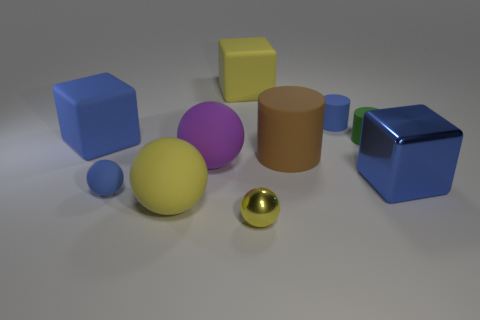Subtract all red spheres. Subtract all gray cylinders. How many spheres are left? 4 Subtract all blocks. How many objects are left? 7 Subtract all big metal cubes. Subtract all blue metallic blocks. How many objects are left? 8 Add 5 large yellow cubes. How many large yellow cubes are left? 6 Add 3 rubber cubes. How many rubber cubes exist? 5 Subtract 0 purple cylinders. How many objects are left? 10 